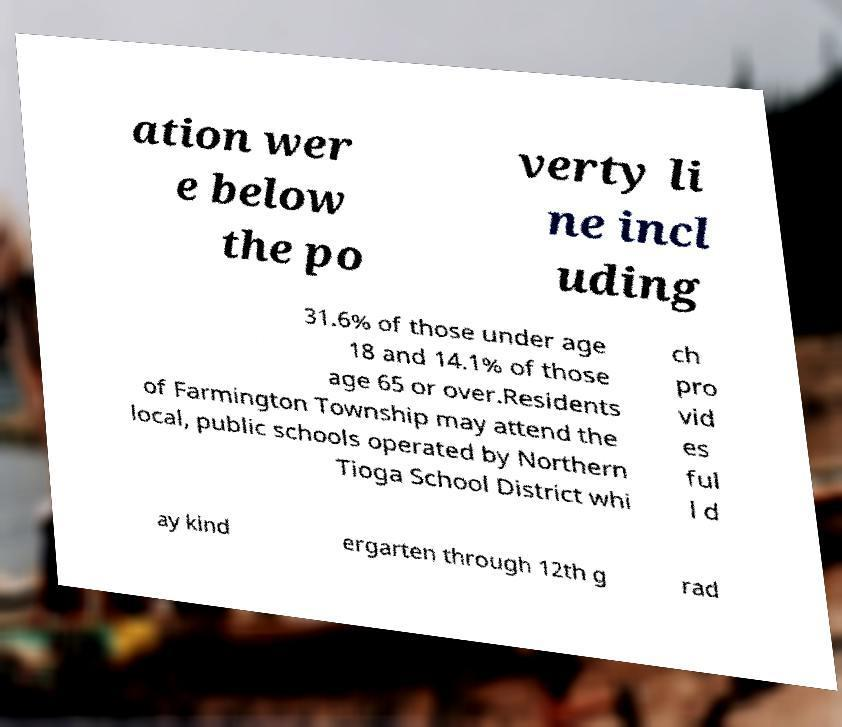Could you assist in decoding the text presented in this image and type it out clearly? ation wer e below the po verty li ne incl uding 31.6% of those under age 18 and 14.1% of those age 65 or over.Residents of Farmington Township may attend the local, public schools operated by Northern Tioga School District whi ch pro vid es ful l d ay kind ergarten through 12th g rad 